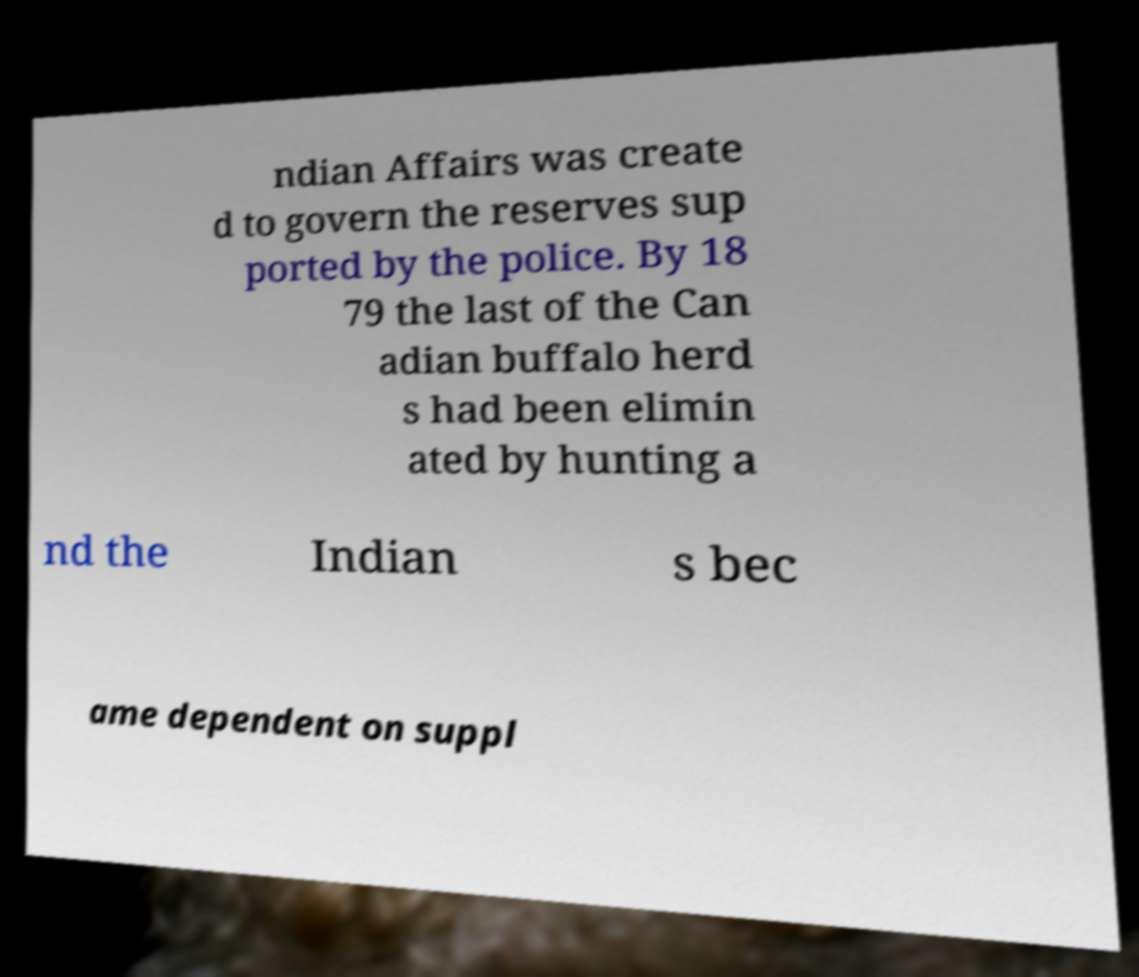Could you extract and type out the text from this image? ndian Affairs was create d to govern the reserves sup ported by the police. By 18 79 the last of the Can adian buffalo herd s had been elimin ated by hunting a nd the Indian s bec ame dependent on suppl 